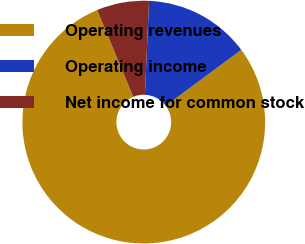Convert chart. <chart><loc_0><loc_0><loc_500><loc_500><pie_chart><fcel>Operating revenues<fcel>Operating income<fcel>Net income for common stock<nl><fcel>78.88%<fcel>14.16%<fcel>6.96%<nl></chart> 